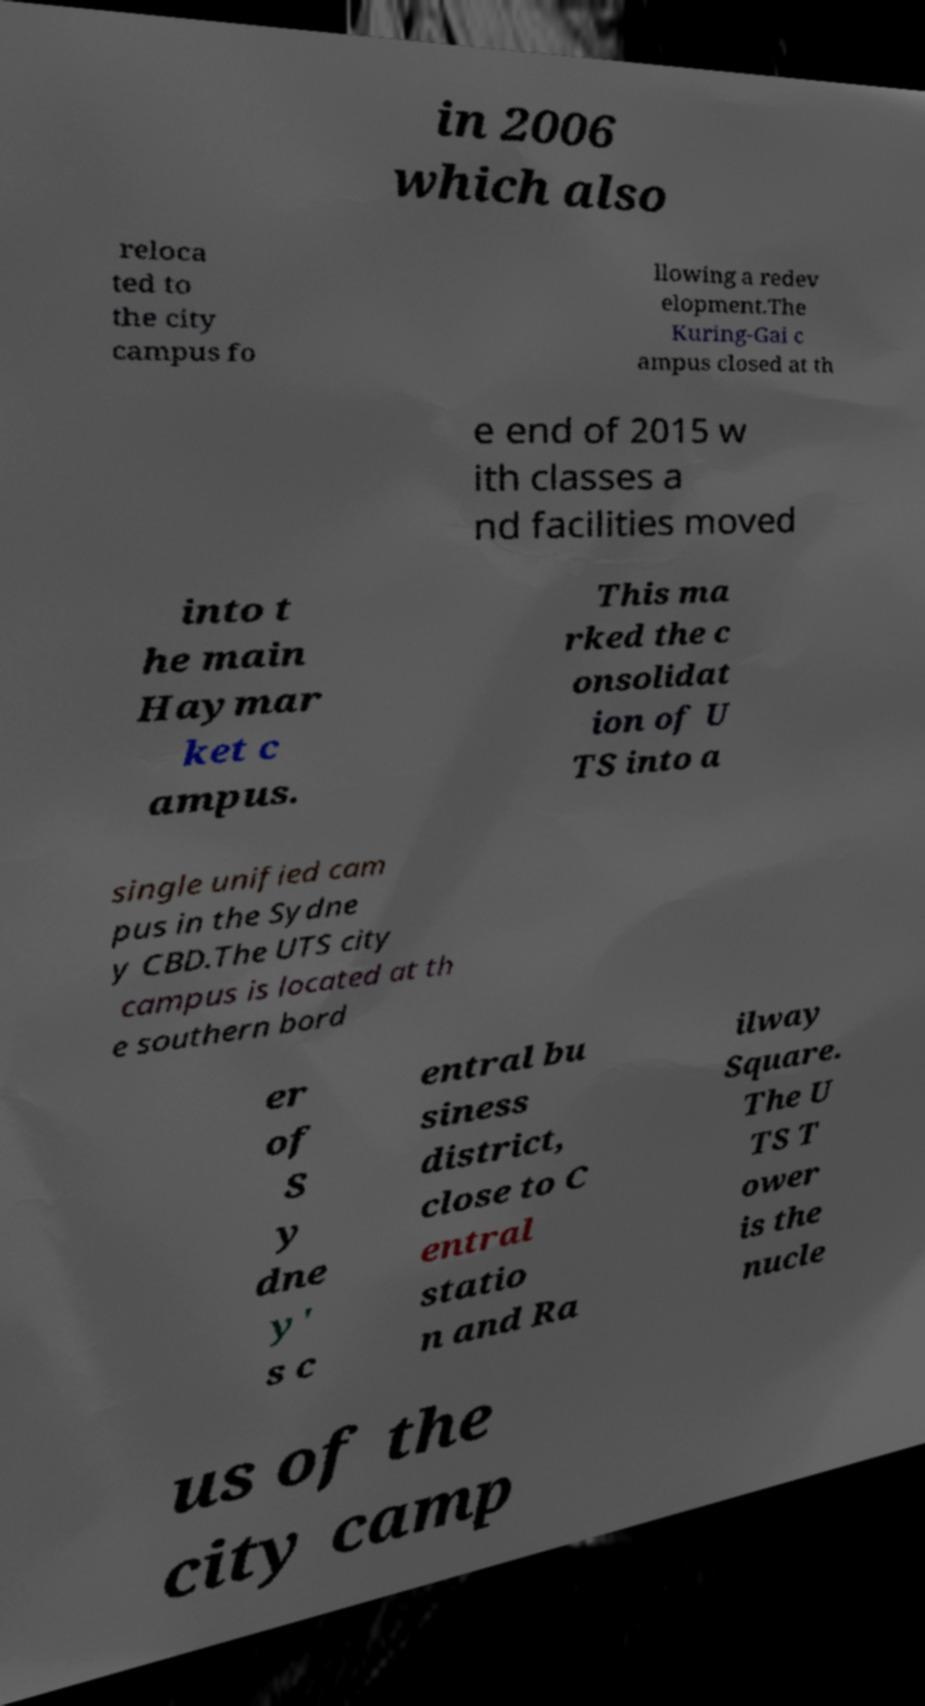Please identify and transcribe the text found in this image. in 2006 which also reloca ted to the city campus fo llowing a redev elopment.The Kuring-Gai c ampus closed at th e end of 2015 w ith classes a nd facilities moved into t he main Haymar ket c ampus. This ma rked the c onsolidat ion of U TS into a single unified cam pus in the Sydne y CBD.The UTS city campus is located at th e southern bord er of S y dne y' s c entral bu siness district, close to C entral statio n and Ra ilway Square. The U TS T ower is the nucle us of the city camp 